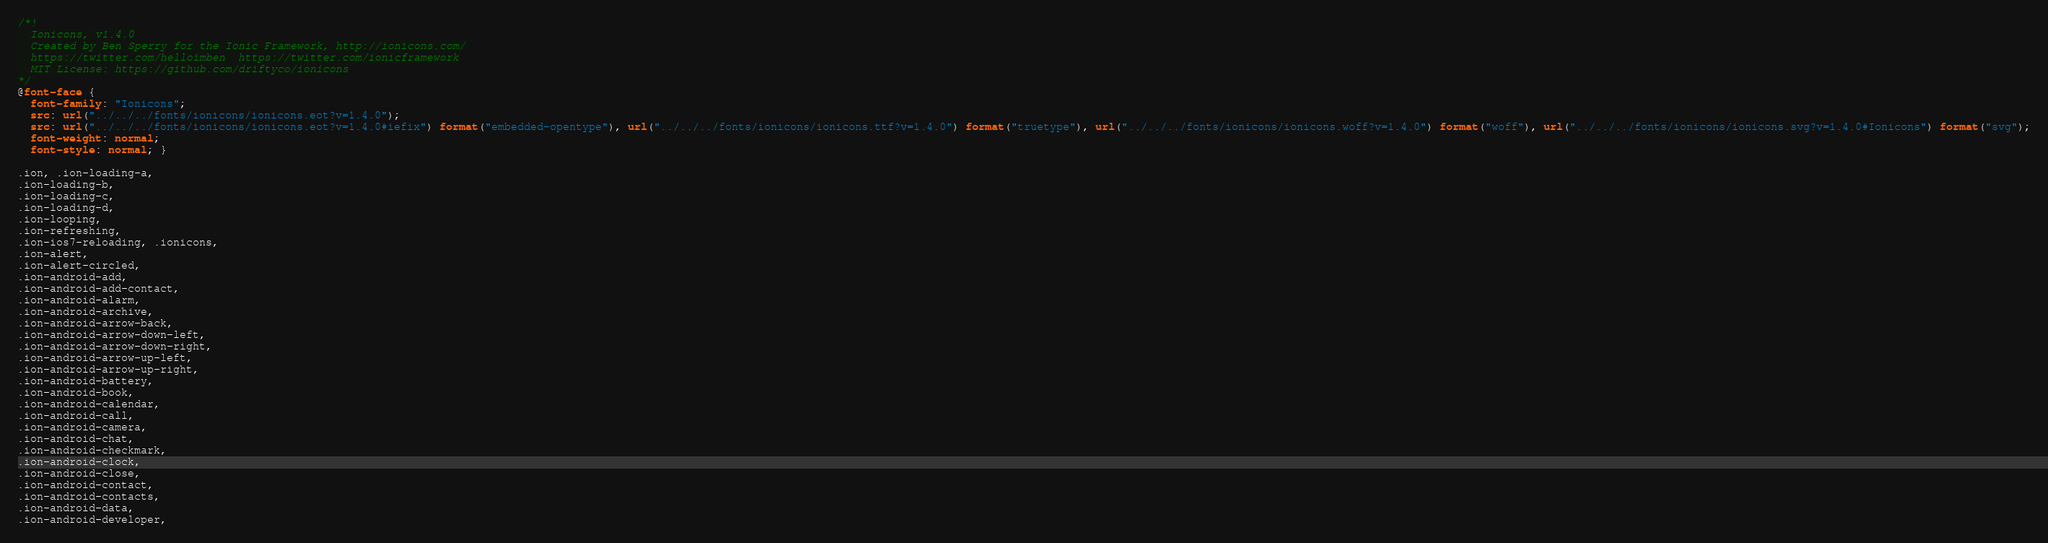<code> <loc_0><loc_0><loc_500><loc_500><_CSS_>/*!
  Ionicons, v1.4.0
  Created by Ben Sperry for the Ionic Framework, http://ionicons.com/
  https://twitter.com/helloimben  https://twitter.com/ionicframework
  MIT License: https://github.com/driftyco/ionicons
*/
@font-face {
  font-family: "Ionicons";
  src: url("../../../fonts/ionicons/ionicons.eot?v=1.4.0");
  src: url("../../../fonts/ionicons/ionicons.eot?v=1.4.0#iefix") format("embedded-opentype"), url("../../../fonts/ionicons/ionicons.ttf?v=1.4.0") format("truetype"), url("../../../fonts/ionicons/ionicons.woff?v=1.4.0") format("woff"), url("../../../fonts/ionicons/ionicons.svg?v=1.4.0#Ionicons") format("svg");
  font-weight: normal;
  font-style: normal; }

.ion, .ion-loading-a,
.ion-loading-b,
.ion-loading-c,
.ion-loading-d,
.ion-looping,
.ion-refreshing,
.ion-ios7-reloading, .ionicons,
.ion-alert,
.ion-alert-circled,
.ion-android-add,
.ion-android-add-contact,
.ion-android-alarm,
.ion-android-archive,
.ion-android-arrow-back,
.ion-android-arrow-down-left,
.ion-android-arrow-down-right,
.ion-android-arrow-up-left,
.ion-android-arrow-up-right,
.ion-android-battery,
.ion-android-book,
.ion-android-calendar,
.ion-android-call,
.ion-android-camera,
.ion-android-chat,
.ion-android-checkmark,
.ion-android-clock,
.ion-android-close,
.ion-android-contact,
.ion-android-contacts,
.ion-android-data,
.ion-android-developer,</code> 